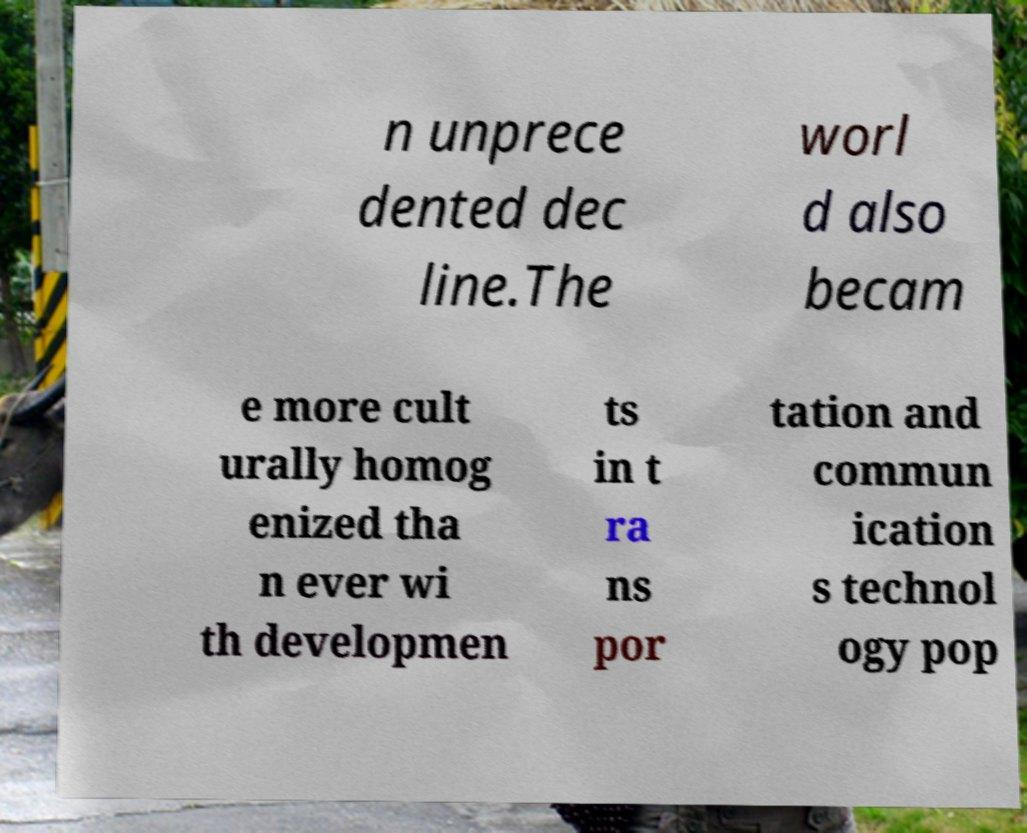There's text embedded in this image that I need extracted. Can you transcribe it verbatim? n unprece dented dec line.The worl d also becam e more cult urally homog enized tha n ever wi th developmen ts in t ra ns por tation and commun ication s technol ogy pop 